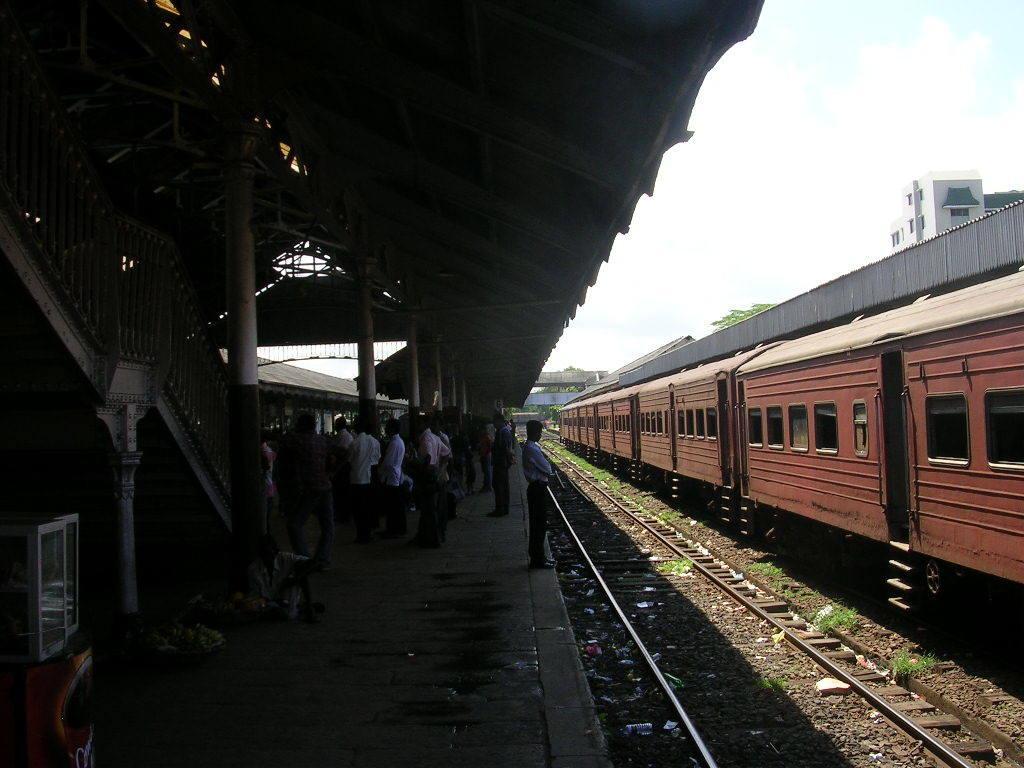Could you give a brief overview of what you see in this image? On the left side, there are persons in different color dresses on a platform, which is having a roof and poles and there are other objects. On the right side, there is a train on a railway track. Beside this train, there is another railway track. Behind this train, there is another platform having a roof. In the background, there are buildings, trees, a bridge and there are clouds in the sky. 